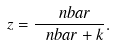Convert formula to latex. <formula><loc_0><loc_0><loc_500><loc_500>z = \frac { \ n b a r } { \ n b a r + k } .</formula> 